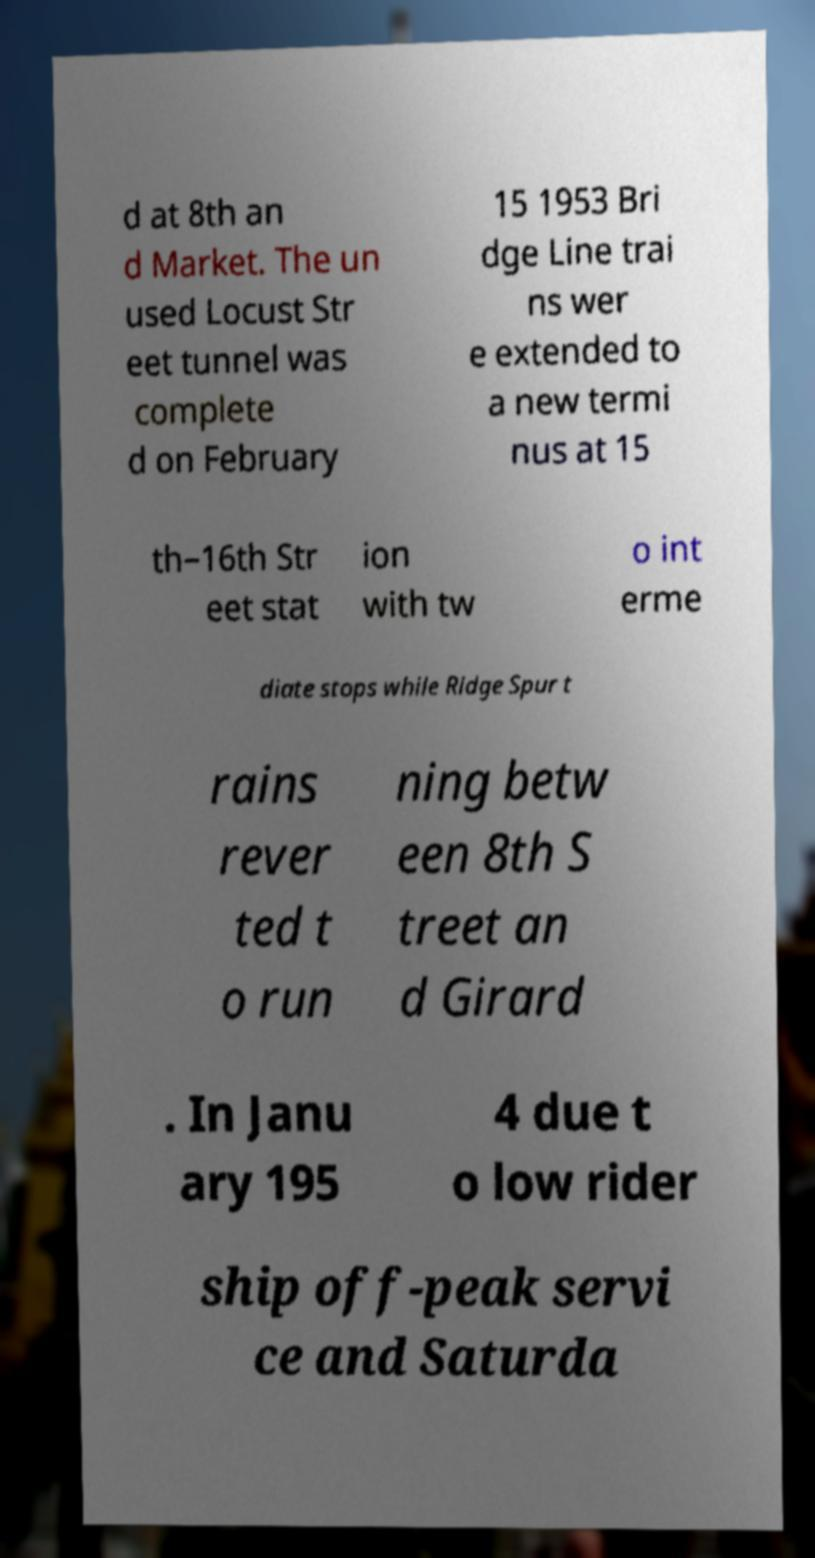For documentation purposes, I need the text within this image transcribed. Could you provide that? d at 8th an d Market. The un used Locust Str eet tunnel was complete d on February 15 1953 Bri dge Line trai ns wer e extended to a new termi nus at 15 th–16th Str eet stat ion with tw o int erme diate stops while Ridge Spur t rains rever ted t o run ning betw een 8th S treet an d Girard . In Janu ary 195 4 due t o low rider ship off-peak servi ce and Saturda 